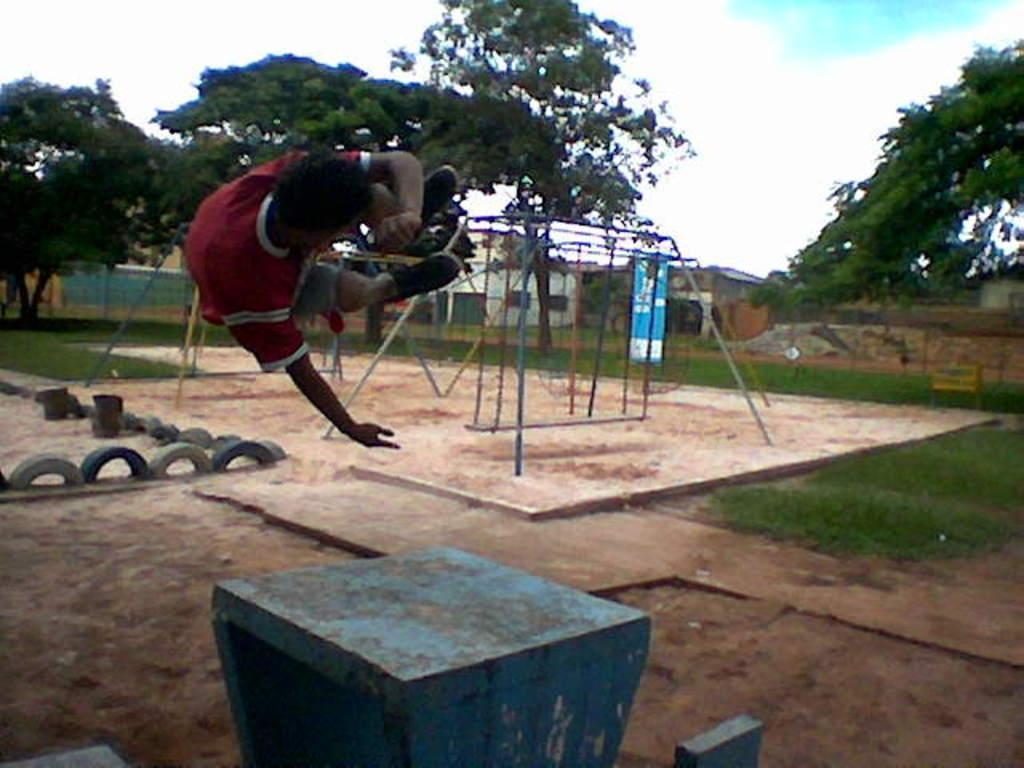In one or two sentences, can you explain what this image depicts? In this image we can see a person jumping. In the center there is a swing. At the bottom we can see a pedestal. On the left there are tires. In the background there are trees and sky. We can see grass. 